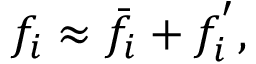Convert formula to latex. <formula><loc_0><loc_0><loc_500><loc_500>f _ { i } \approx \bar { f } _ { i } + f _ { i } ^ { ^ { \prime } } ,</formula> 